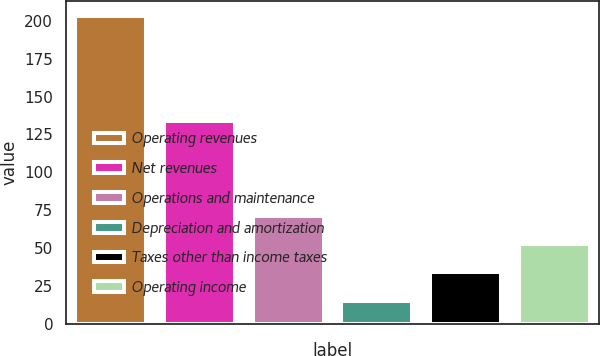Convert chart to OTSL. <chart><loc_0><loc_0><loc_500><loc_500><bar_chart><fcel>Operating revenues<fcel>Net revenues<fcel>Operations and maintenance<fcel>Depreciation and amortization<fcel>Taxes other than income taxes<fcel>Operating income<nl><fcel>203<fcel>134<fcel>71.4<fcel>15<fcel>33.8<fcel>52.6<nl></chart> 